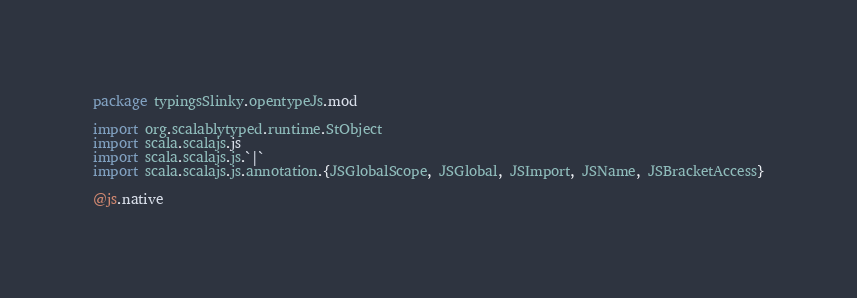<code> <loc_0><loc_0><loc_500><loc_500><_Scala_>package typingsSlinky.opentypeJs.mod

import org.scalablytyped.runtime.StObject
import scala.scalajs.js
import scala.scalajs.js.`|`
import scala.scalajs.js.annotation.{JSGlobalScope, JSGlobal, JSImport, JSName, JSBracketAccess}

@js.native</code> 